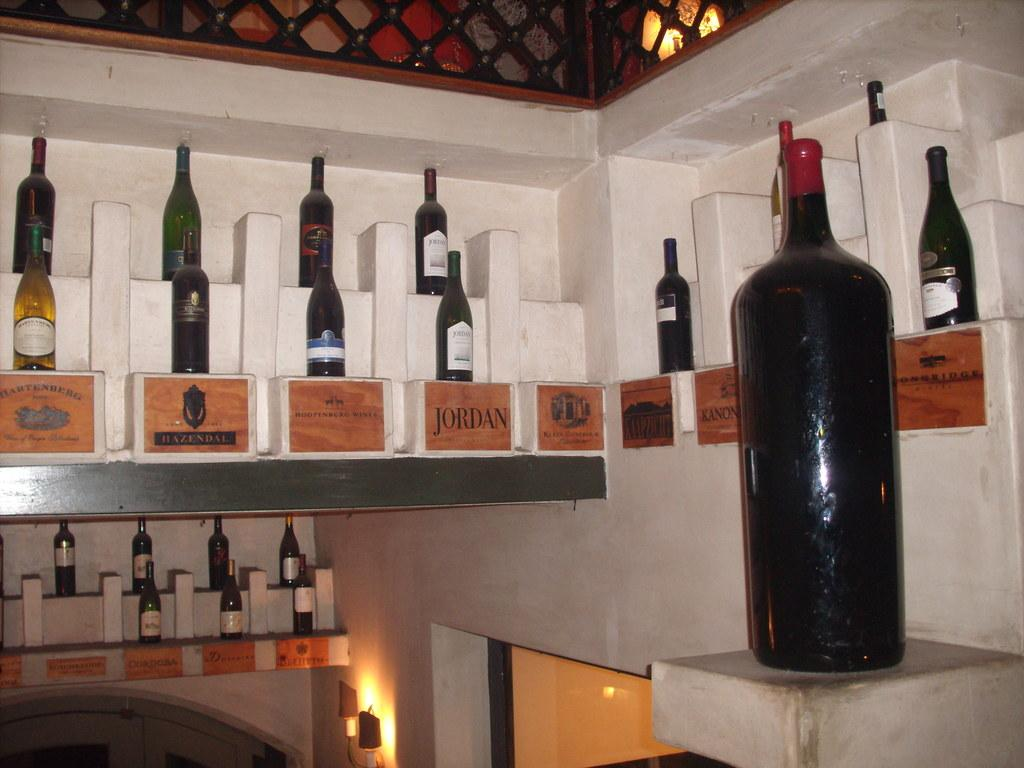<image>
Write a terse but informative summary of the picture. A display featuring several wine bottles including one called Jordan. 